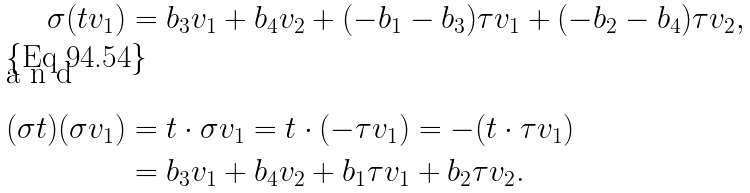<formula> <loc_0><loc_0><loc_500><loc_500>\sigma ( t v _ { 1 } ) & = b _ { 3 } v _ { 1 } + b _ { 4 } v _ { 2 } + ( - b _ { 1 } - b _ { 3 } ) \tau v _ { 1 } + ( - b _ { 2 } - b _ { 4 } ) \tau v _ { 2 } , \\ \intertext { a n d } ( \sigma t ) ( \sigma v _ { 1 } ) & = t \cdot \sigma v _ { 1 } = t \cdot ( - \tau v _ { 1 } ) = - ( t \cdot \tau v _ { 1 } ) \\ & = b _ { 3 } v _ { 1 } + b _ { 4 } v _ { 2 } + b _ { 1 } \tau v _ { 1 } + b _ { 2 } \tau v _ { 2 } .</formula> 